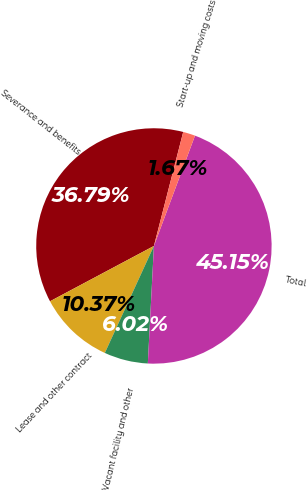<chart> <loc_0><loc_0><loc_500><loc_500><pie_chart><fcel>Severance and benefits<fcel>Lease and other contract<fcel>Vacant facility and other<fcel>Total<fcel>Start-up and moving costs<nl><fcel>36.79%<fcel>10.37%<fcel>6.02%<fcel>45.15%<fcel>1.67%<nl></chart> 